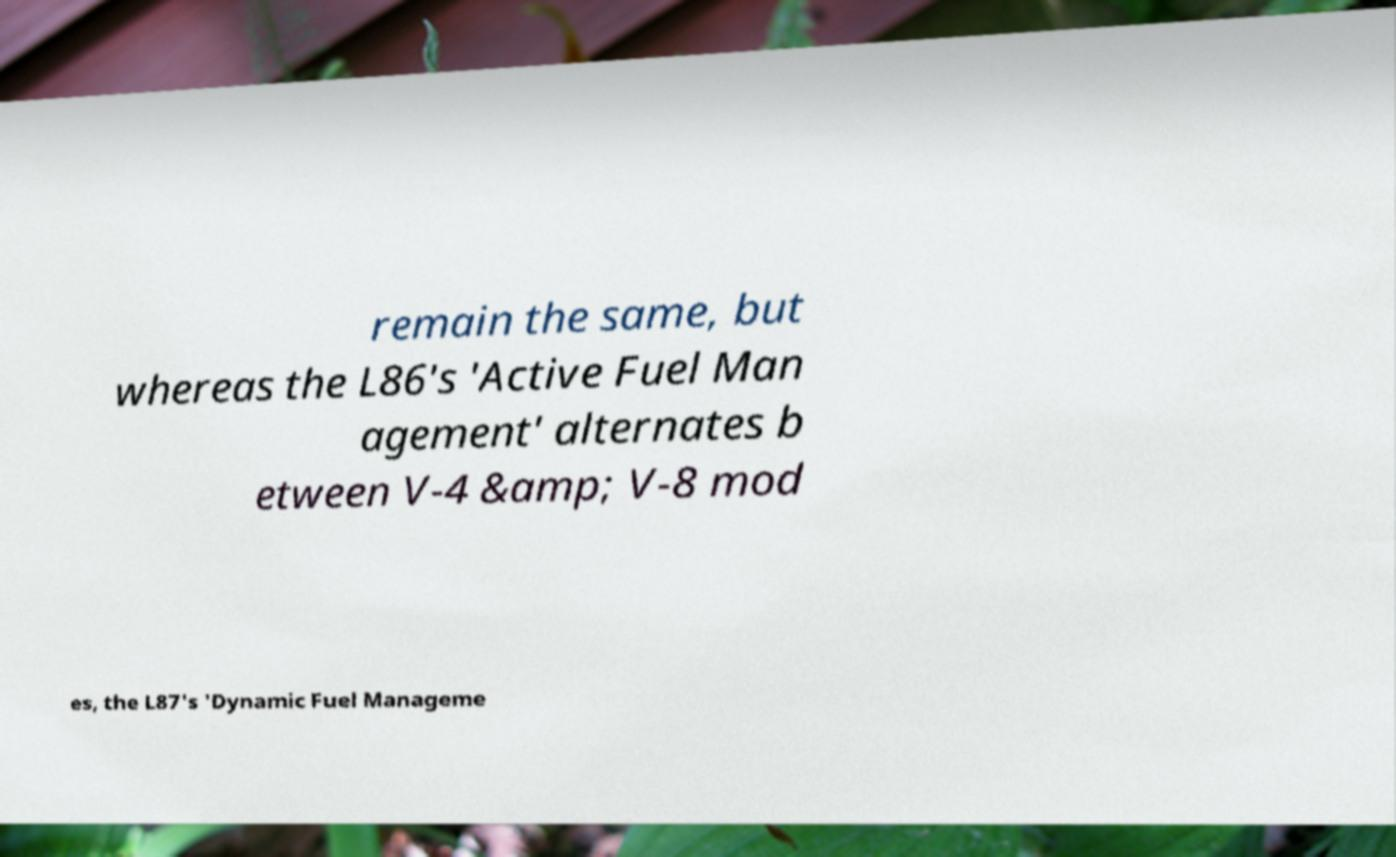Can you read and provide the text displayed in the image?This photo seems to have some interesting text. Can you extract and type it out for me? remain the same, but whereas the L86's 'Active Fuel Man agement' alternates b etween V-4 &amp; V-8 mod es, the L87's 'Dynamic Fuel Manageme 